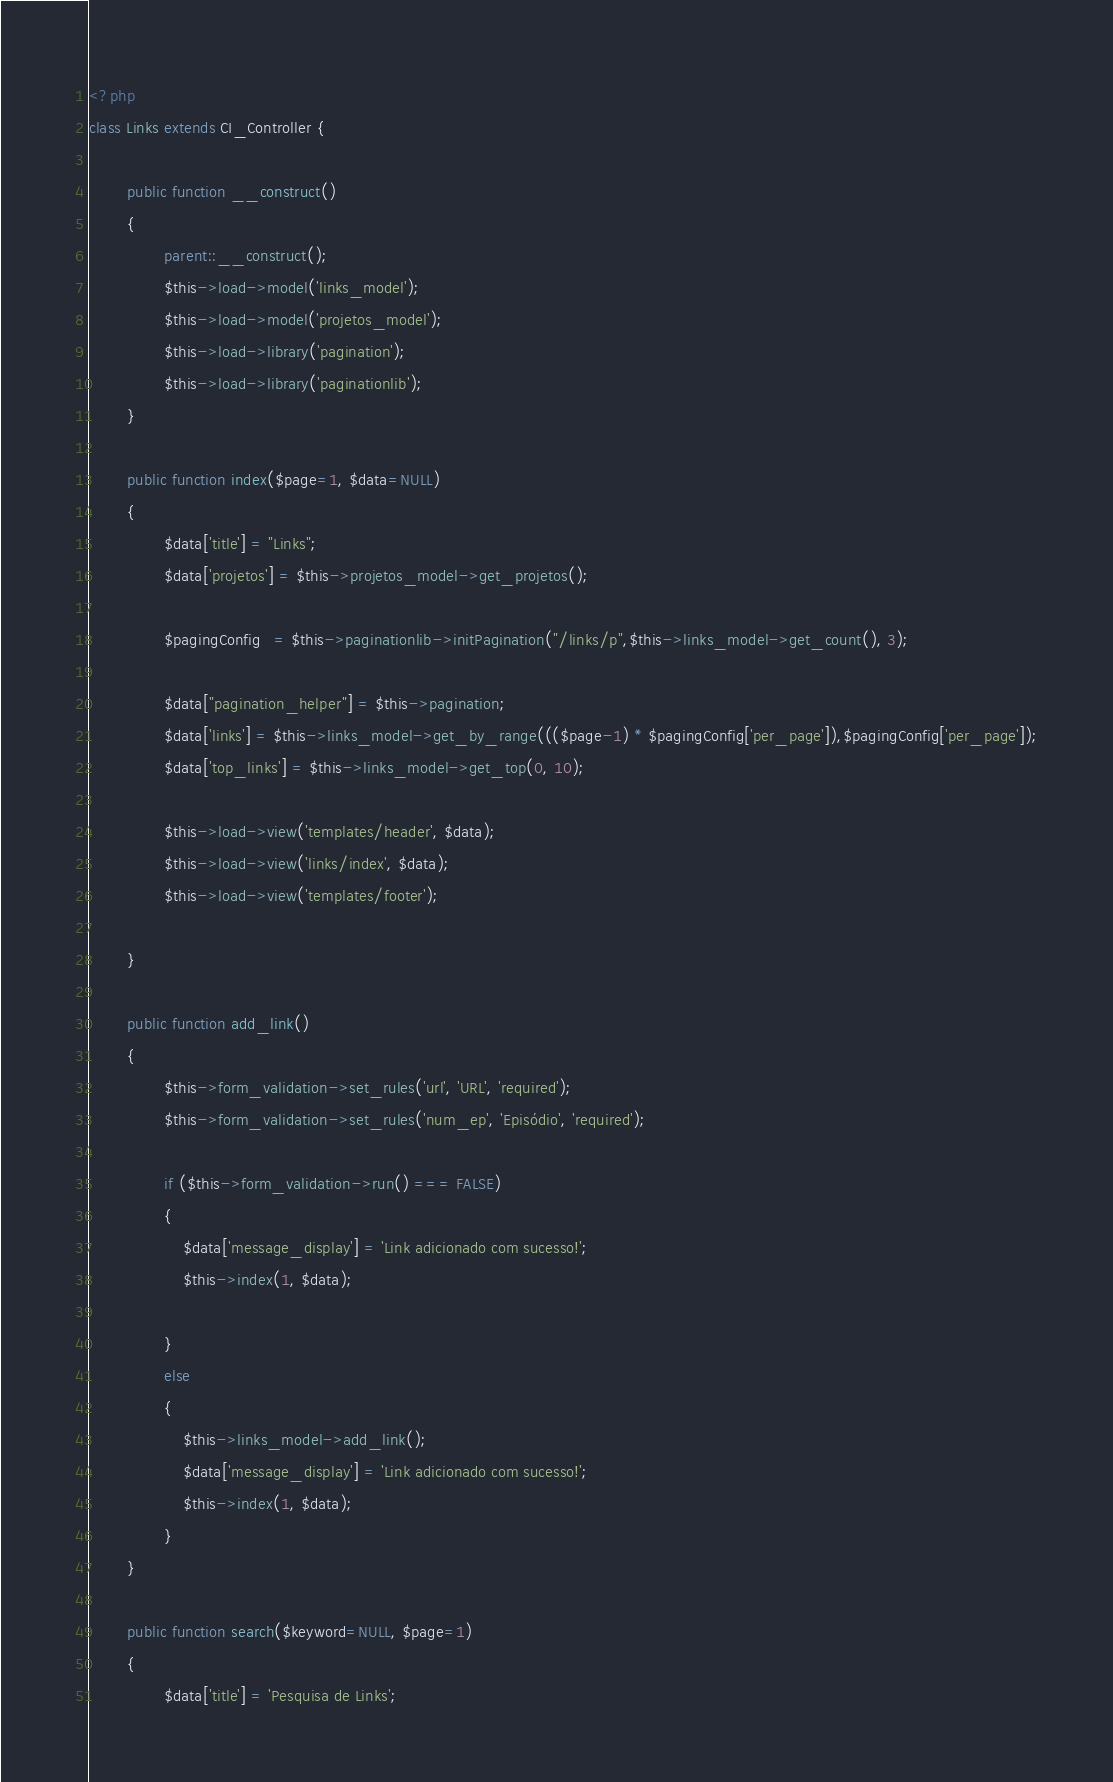Convert code to text. <code><loc_0><loc_0><loc_500><loc_500><_PHP_><?php
class Links extends CI_Controller {

        public function __construct()
        {
                parent::__construct();
                $this->load->model('links_model');
                $this->load->model('projetos_model');
                $this->load->library('pagination');
        		$this->load->library('paginationlib');
        }

        public function index($page=1, $data=NULL)
        {
                $data['title'] = "Links";
                $data['projetos'] = $this->projetos_model->get_projetos();

           		$pagingConfig   = $this->paginationlib->initPagination("/links/p",$this->links_model->get_count(), 3);
           
           		$data["pagination_helper"] = $this->pagination;
           		$data['links'] = $this->links_model->get_by_range((($page-1) * $pagingConfig['per_page']),$pagingConfig['per_page']);
           		$data['top_links'] = $this->links_model->get_top(0, 10);
            
           		$this->load->view('templates/header', $data);
               	$this->load->view('links/index', $data);
               	$this->load->view('templates/footer');            

        }

        public function add_link()
        {
                $this->form_validation->set_rules('url', 'URL', 'required');
                $this->form_validation->set_rules('num_ep', 'Episódio', 'required');

                if ($this->form_validation->run() === FALSE)
                {      
                    $data['message_display'] = 'Link adicionado com sucesso!';
					$this->index(1, $data);

                }
                else
                {
                    $this->links_model->add_link();
                    $data['message_display'] = 'Link adicionado com sucesso!';
                    $this->index(1, $data);
                }
        }

        public function search($keyword=NULL, $page=1)
        {
                $data['title'] = 'Pesquisa de Links';</code> 